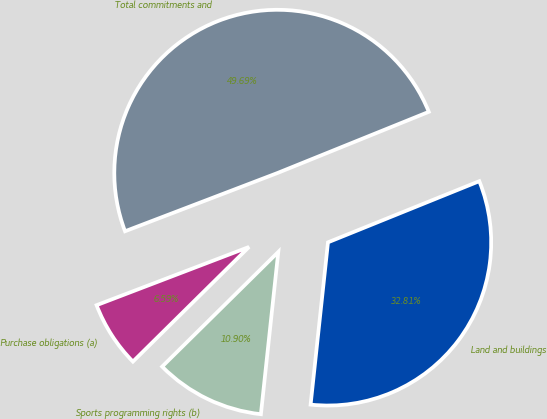<chart> <loc_0><loc_0><loc_500><loc_500><pie_chart><fcel>Purchase obligations (a)<fcel>Sports programming rights (b)<fcel>Land and buildings<fcel>Total commitments and<nl><fcel>6.59%<fcel>10.9%<fcel>32.81%<fcel>49.69%<nl></chart> 